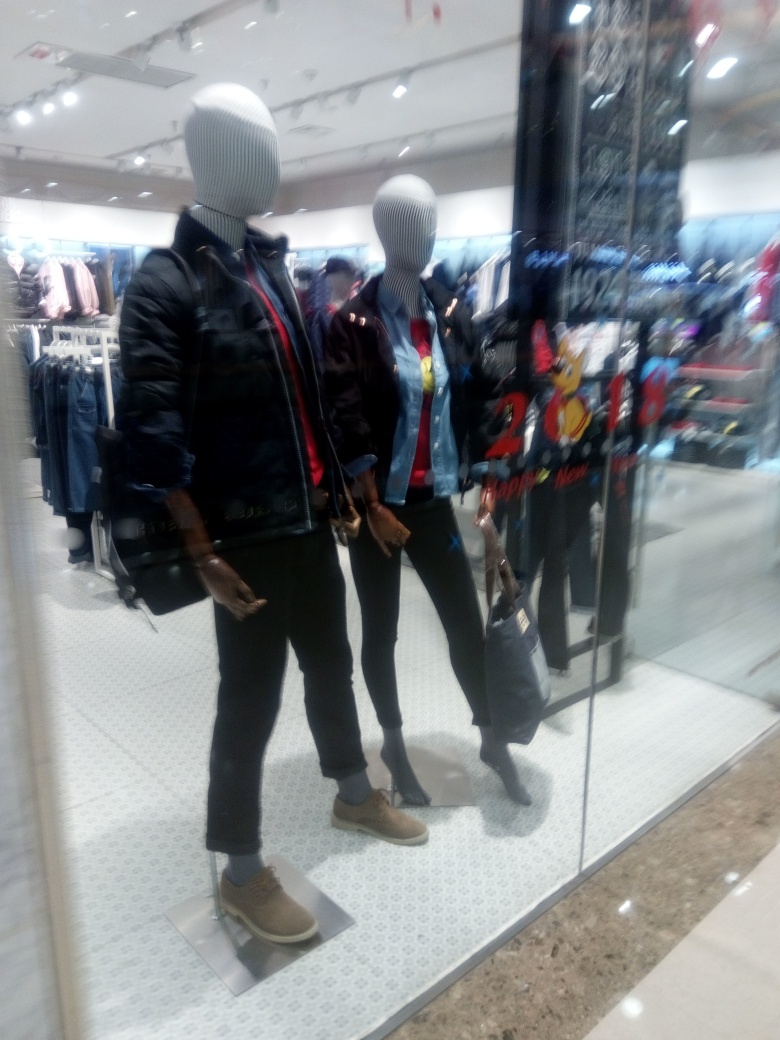Does the image give any indications about the target demographic for these clothes? Yes, the selection of clothing presented on the mannequins, along with the trendy styles and youthful designs, such as the animated character on the t-shirt, suggest that the target demographic for these clothes is likely a young adult audience interested in casual, fashionable attire. 